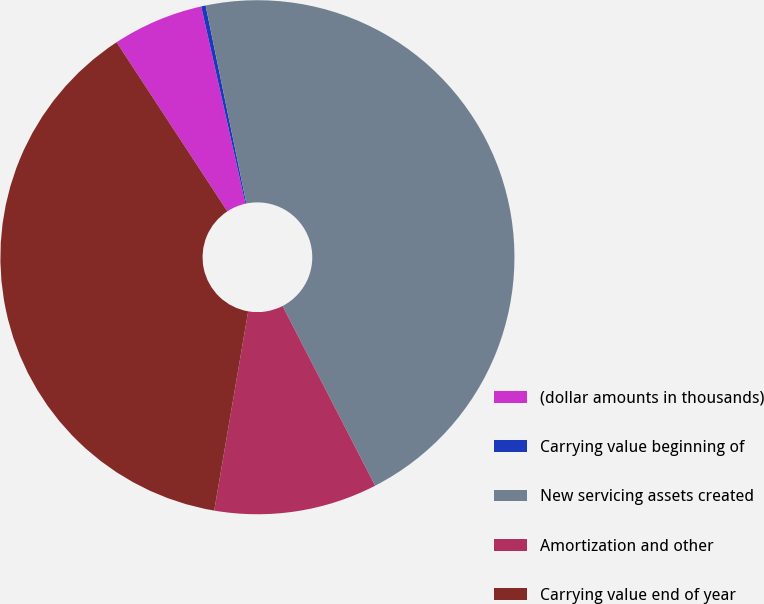Convert chart to OTSL. <chart><loc_0><loc_0><loc_500><loc_500><pie_chart><fcel>(dollar amounts in thousands)<fcel>Carrying value beginning of<fcel>New servicing assets created<fcel>Amortization and other<fcel>Carrying value end of year<nl><fcel>5.72%<fcel>0.28%<fcel>45.66%<fcel>10.26%<fcel>38.08%<nl></chart> 